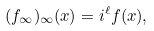<formula> <loc_0><loc_0><loc_500><loc_500>( f _ { \infty } ) _ { \infty } ( x ) = i ^ { \ell } f ( x ) ,</formula> 